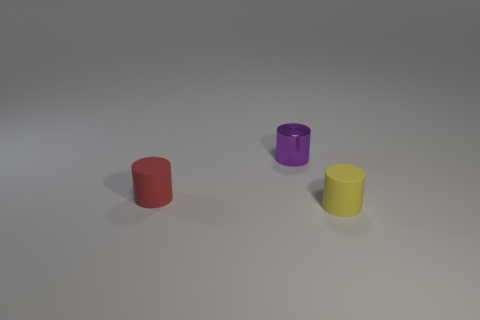Are the tiny yellow cylinder and the tiny thing that is on the left side of the tiny purple shiny cylinder made of the same material?
Give a very brief answer. Yes. What is the color of the small metallic cylinder?
Your answer should be very brief. Purple. What shape is the small object in front of the small red rubber cylinder?
Make the answer very short. Cylinder. What number of brown things are small matte spheres or rubber objects?
Give a very brief answer. 0. What is the color of the object that is the same material as the tiny red cylinder?
Keep it short and to the point. Yellow. There is a small object that is both on the right side of the tiny red cylinder and in front of the small purple metal thing; what is its color?
Provide a succinct answer. Yellow. There is a small purple shiny cylinder; how many tiny metal objects are right of it?
Offer a very short reply. 0. What number of objects are either big purple cylinders or tiny rubber objects that are behind the small yellow cylinder?
Give a very brief answer. 1. Are there any red things to the left of the small yellow rubber cylinder that is right of the red matte cylinder?
Give a very brief answer. Yes. There is a tiny matte thing behind the tiny yellow cylinder; what is its color?
Your response must be concise. Red. 